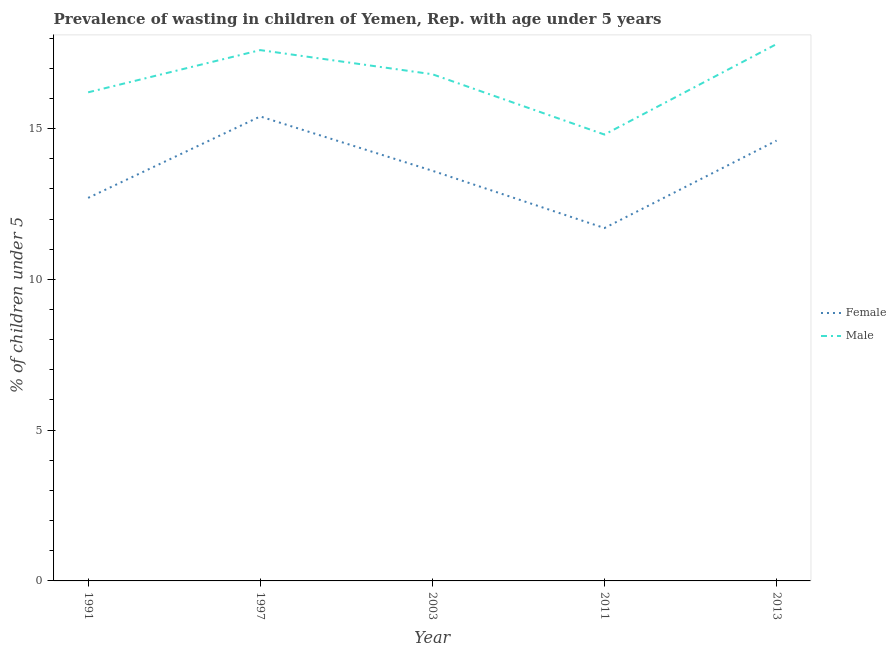What is the percentage of undernourished female children in 2013?
Provide a short and direct response. 14.6. Across all years, what is the maximum percentage of undernourished female children?
Keep it short and to the point. 15.4. Across all years, what is the minimum percentage of undernourished female children?
Keep it short and to the point. 11.7. In which year was the percentage of undernourished male children minimum?
Provide a short and direct response. 2011. What is the total percentage of undernourished male children in the graph?
Provide a succinct answer. 83.2. What is the difference between the percentage of undernourished female children in 1997 and that in 2013?
Your answer should be compact. 0.8. What is the difference between the percentage of undernourished female children in 2011 and the percentage of undernourished male children in 1997?
Provide a short and direct response. -5.9. What is the average percentage of undernourished female children per year?
Provide a short and direct response. 13.6. In the year 2013, what is the difference between the percentage of undernourished female children and percentage of undernourished male children?
Offer a terse response. -3.2. What is the ratio of the percentage of undernourished female children in 1997 to that in 2011?
Make the answer very short. 1.32. What is the difference between the highest and the second highest percentage of undernourished male children?
Offer a very short reply. 0.2. What is the difference between the highest and the lowest percentage of undernourished male children?
Give a very brief answer. 3. Is the sum of the percentage of undernourished male children in 1997 and 2013 greater than the maximum percentage of undernourished female children across all years?
Keep it short and to the point. Yes. Is the percentage of undernourished female children strictly greater than the percentage of undernourished male children over the years?
Provide a succinct answer. No. What is the difference between two consecutive major ticks on the Y-axis?
Your response must be concise. 5. Does the graph contain grids?
Your answer should be compact. No. How many legend labels are there?
Provide a succinct answer. 2. How are the legend labels stacked?
Ensure brevity in your answer.  Vertical. What is the title of the graph?
Give a very brief answer. Prevalence of wasting in children of Yemen, Rep. with age under 5 years. What is the label or title of the X-axis?
Give a very brief answer. Year. What is the label or title of the Y-axis?
Your response must be concise.  % of children under 5. What is the  % of children under 5 in Female in 1991?
Your answer should be very brief. 12.7. What is the  % of children under 5 of Male in 1991?
Offer a very short reply. 16.2. What is the  % of children under 5 in Female in 1997?
Make the answer very short. 15.4. What is the  % of children under 5 of Male in 1997?
Your answer should be compact. 17.6. What is the  % of children under 5 in Female in 2003?
Provide a short and direct response. 13.6. What is the  % of children under 5 of Male in 2003?
Offer a terse response. 16.8. What is the  % of children under 5 in Female in 2011?
Offer a terse response. 11.7. What is the  % of children under 5 in Male in 2011?
Your answer should be compact. 14.8. What is the  % of children under 5 of Female in 2013?
Provide a short and direct response. 14.6. What is the  % of children under 5 of Male in 2013?
Offer a very short reply. 17.8. Across all years, what is the maximum  % of children under 5 in Female?
Make the answer very short. 15.4. Across all years, what is the maximum  % of children under 5 of Male?
Provide a succinct answer. 17.8. Across all years, what is the minimum  % of children under 5 of Female?
Offer a very short reply. 11.7. Across all years, what is the minimum  % of children under 5 of Male?
Make the answer very short. 14.8. What is the total  % of children under 5 in Female in the graph?
Provide a succinct answer. 68. What is the total  % of children under 5 of Male in the graph?
Provide a succinct answer. 83.2. What is the difference between the  % of children under 5 of Female in 1991 and that in 2003?
Ensure brevity in your answer.  -0.9. What is the difference between the  % of children under 5 of Female in 1991 and that in 2011?
Your response must be concise. 1. What is the difference between the  % of children under 5 of Female in 1997 and that in 2003?
Offer a very short reply. 1.8. What is the difference between the  % of children under 5 in Female in 1997 and that in 2011?
Offer a very short reply. 3.7. What is the difference between the  % of children under 5 in Male in 1997 and that in 2011?
Your answer should be compact. 2.8. What is the difference between the  % of children under 5 of Female in 2003 and that in 2011?
Provide a succinct answer. 1.9. What is the difference between the  % of children under 5 in Male in 2003 and that in 2011?
Give a very brief answer. 2. What is the difference between the  % of children under 5 in Female in 2003 and that in 2013?
Make the answer very short. -1. What is the difference between the  % of children under 5 in Male in 2003 and that in 2013?
Ensure brevity in your answer.  -1. What is the difference between the  % of children under 5 of Female in 1991 and the  % of children under 5 of Male in 2003?
Offer a terse response. -4.1. What is the difference between the  % of children under 5 of Female in 1991 and the  % of children under 5 of Male in 2011?
Provide a short and direct response. -2.1. What is the difference between the  % of children under 5 of Female in 1991 and the  % of children under 5 of Male in 2013?
Your response must be concise. -5.1. What is the difference between the  % of children under 5 of Female in 1997 and the  % of children under 5 of Male in 2003?
Make the answer very short. -1.4. What is the difference between the  % of children under 5 in Female in 1997 and the  % of children under 5 in Male in 2011?
Offer a terse response. 0.6. What is the difference between the  % of children under 5 of Female in 1997 and the  % of children under 5 of Male in 2013?
Provide a succinct answer. -2.4. What is the difference between the  % of children under 5 of Female in 2011 and the  % of children under 5 of Male in 2013?
Give a very brief answer. -6.1. What is the average  % of children under 5 in Female per year?
Provide a succinct answer. 13.6. What is the average  % of children under 5 of Male per year?
Offer a very short reply. 16.64. In the year 1991, what is the difference between the  % of children under 5 of Female and  % of children under 5 of Male?
Provide a succinct answer. -3.5. In the year 2003, what is the difference between the  % of children under 5 in Female and  % of children under 5 in Male?
Give a very brief answer. -3.2. What is the ratio of the  % of children under 5 in Female in 1991 to that in 1997?
Your answer should be compact. 0.82. What is the ratio of the  % of children under 5 of Male in 1991 to that in 1997?
Offer a very short reply. 0.92. What is the ratio of the  % of children under 5 in Female in 1991 to that in 2003?
Offer a very short reply. 0.93. What is the ratio of the  % of children under 5 in Female in 1991 to that in 2011?
Provide a succinct answer. 1.09. What is the ratio of the  % of children under 5 of Male in 1991 to that in 2011?
Provide a short and direct response. 1.09. What is the ratio of the  % of children under 5 of Female in 1991 to that in 2013?
Offer a terse response. 0.87. What is the ratio of the  % of children under 5 of Male in 1991 to that in 2013?
Provide a succinct answer. 0.91. What is the ratio of the  % of children under 5 of Female in 1997 to that in 2003?
Ensure brevity in your answer.  1.13. What is the ratio of the  % of children under 5 in Male in 1997 to that in 2003?
Offer a terse response. 1.05. What is the ratio of the  % of children under 5 of Female in 1997 to that in 2011?
Your answer should be very brief. 1.32. What is the ratio of the  % of children under 5 in Male in 1997 to that in 2011?
Your answer should be compact. 1.19. What is the ratio of the  % of children under 5 of Female in 1997 to that in 2013?
Make the answer very short. 1.05. What is the ratio of the  % of children under 5 of Male in 1997 to that in 2013?
Offer a very short reply. 0.99. What is the ratio of the  % of children under 5 in Female in 2003 to that in 2011?
Offer a very short reply. 1.16. What is the ratio of the  % of children under 5 of Male in 2003 to that in 2011?
Offer a very short reply. 1.14. What is the ratio of the  % of children under 5 of Female in 2003 to that in 2013?
Provide a short and direct response. 0.93. What is the ratio of the  % of children under 5 in Male in 2003 to that in 2013?
Your answer should be compact. 0.94. What is the ratio of the  % of children under 5 in Female in 2011 to that in 2013?
Your answer should be very brief. 0.8. What is the ratio of the  % of children under 5 of Male in 2011 to that in 2013?
Offer a very short reply. 0.83. What is the difference between the highest and the lowest  % of children under 5 of Female?
Make the answer very short. 3.7. 